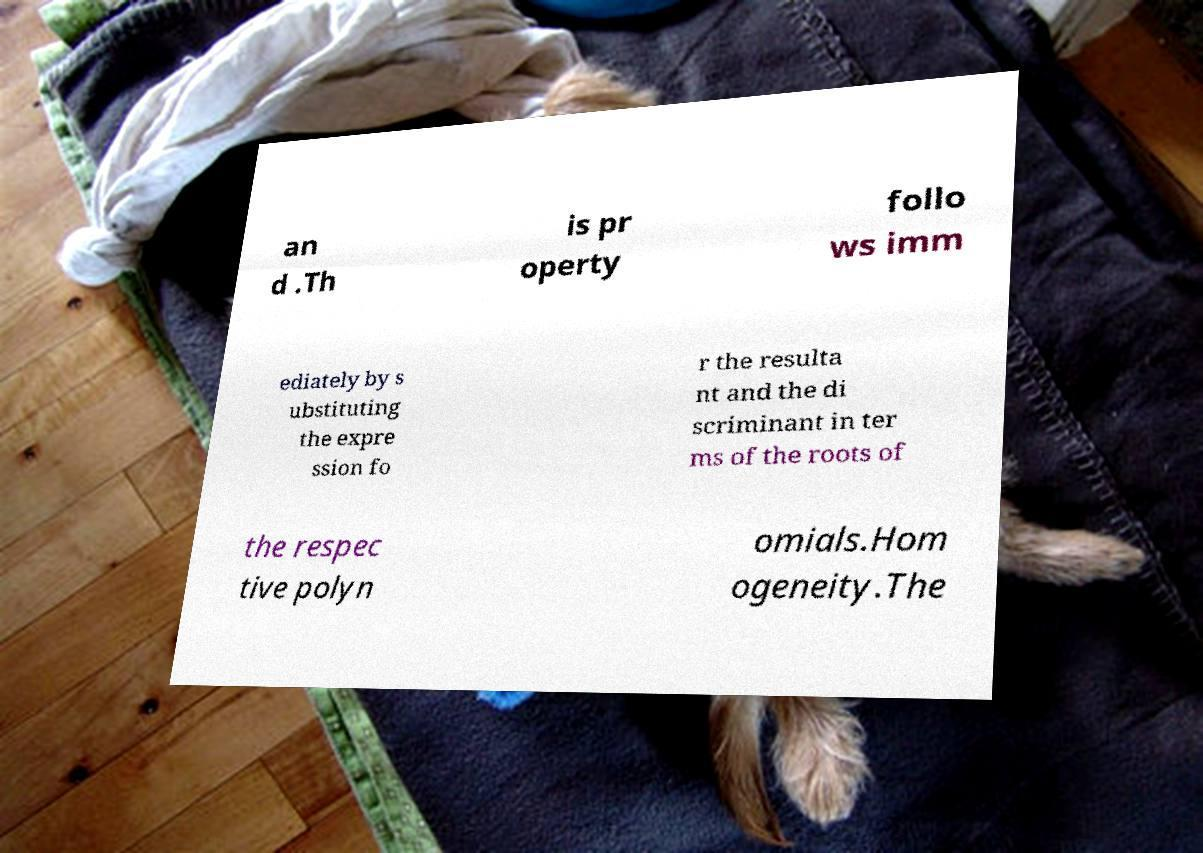There's text embedded in this image that I need extracted. Can you transcribe it verbatim? an d .Th is pr operty follo ws imm ediately by s ubstituting the expre ssion fo r the resulta nt and the di scriminant in ter ms of the roots of the respec tive polyn omials.Hom ogeneity.The 